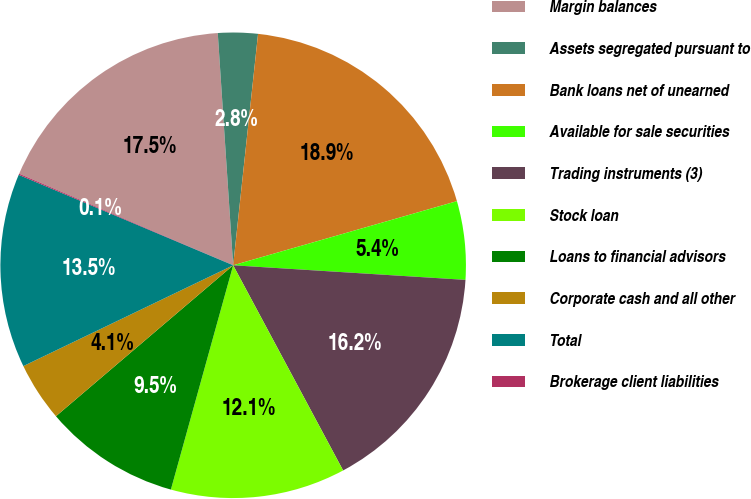Convert chart to OTSL. <chart><loc_0><loc_0><loc_500><loc_500><pie_chart><fcel>Margin balances<fcel>Assets segregated pursuant to<fcel>Bank loans net of unearned<fcel>Available for sale securities<fcel>Trading instruments (3)<fcel>Stock loan<fcel>Loans to financial advisors<fcel>Corporate cash and all other<fcel>Total<fcel>Brokerage client liabilities<nl><fcel>17.51%<fcel>2.76%<fcel>18.85%<fcel>5.44%<fcel>16.17%<fcel>12.14%<fcel>9.46%<fcel>4.1%<fcel>13.48%<fcel>0.08%<nl></chart> 